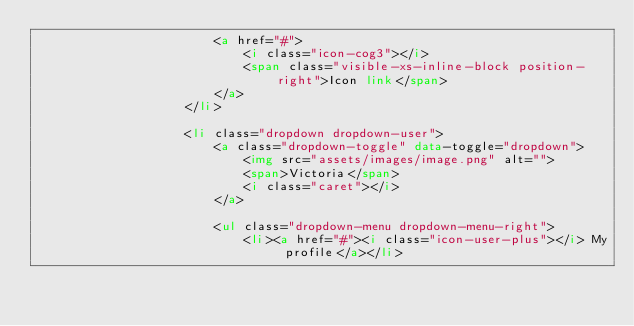<code> <loc_0><loc_0><loc_500><loc_500><_HTML_>						<a href="#">
							<i class="icon-cog3"></i>
							<span class="visible-xs-inline-block position-right">Icon link</span>
						</a>						
					</li>

					<li class="dropdown dropdown-user">
						<a class="dropdown-toggle" data-toggle="dropdown">
							<img src="assets/images/image.png" alt="">
							<span>Victoria</span>
							<i class="caret"></i>
						</a>

						<ul class="dropdown-menu dropdown-menu-right">
							<li><a href="#"><i class="icon-user-plus"></i> My profile</a></li></code> 